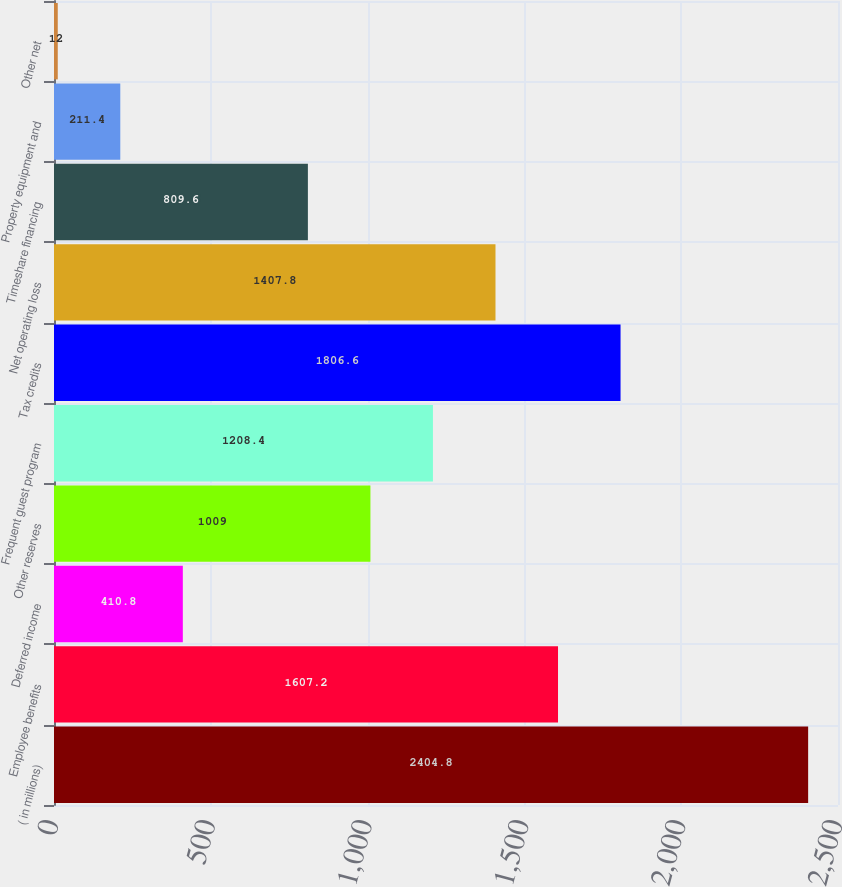Convert chart. <chart><loc_0><loc_0><loc_500><loc_500><bar_chart><fcel>( in millions)<fcel>Employee benefits<fcel>Deferred income<fcel>Other reserves<fcel>Frequent guest program<fcel>Tax credits<fcel>Net operating loss<fcel>Timeshare financing<fcel>Property equipment and<fcel>Other net<nl><fcel>2404.8<fcel>1607.2<fcel>410.8<fcel>1009<fcel>1208.4<fcel>1806.6<fcel>1407.8<fcel>809.6<fcel>211.4<fcel>12<nl></chart> 